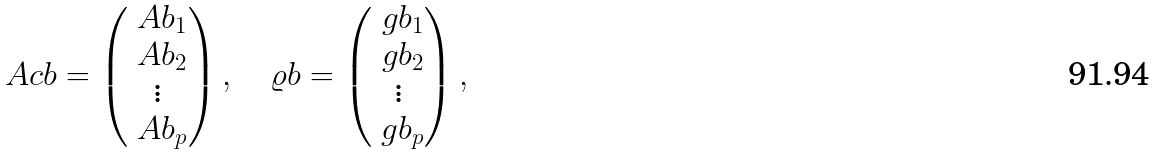<formula> <loc_0><loc_0><loc_500><loc_500>\ A c b = \begin{pmatrix} \ A b _ { 1 } \\ \ A b _ { 2 } \\ \vdots \\ \ A b _ { p } \end{pmatrix} , \quad \varrho b = \begin{pmatrix} \ g b _ { 1 } \\ \ g b _ { 2 } \\ \vdots \\ \ g b _ { p } \end{pmatrix} ,</formula> 